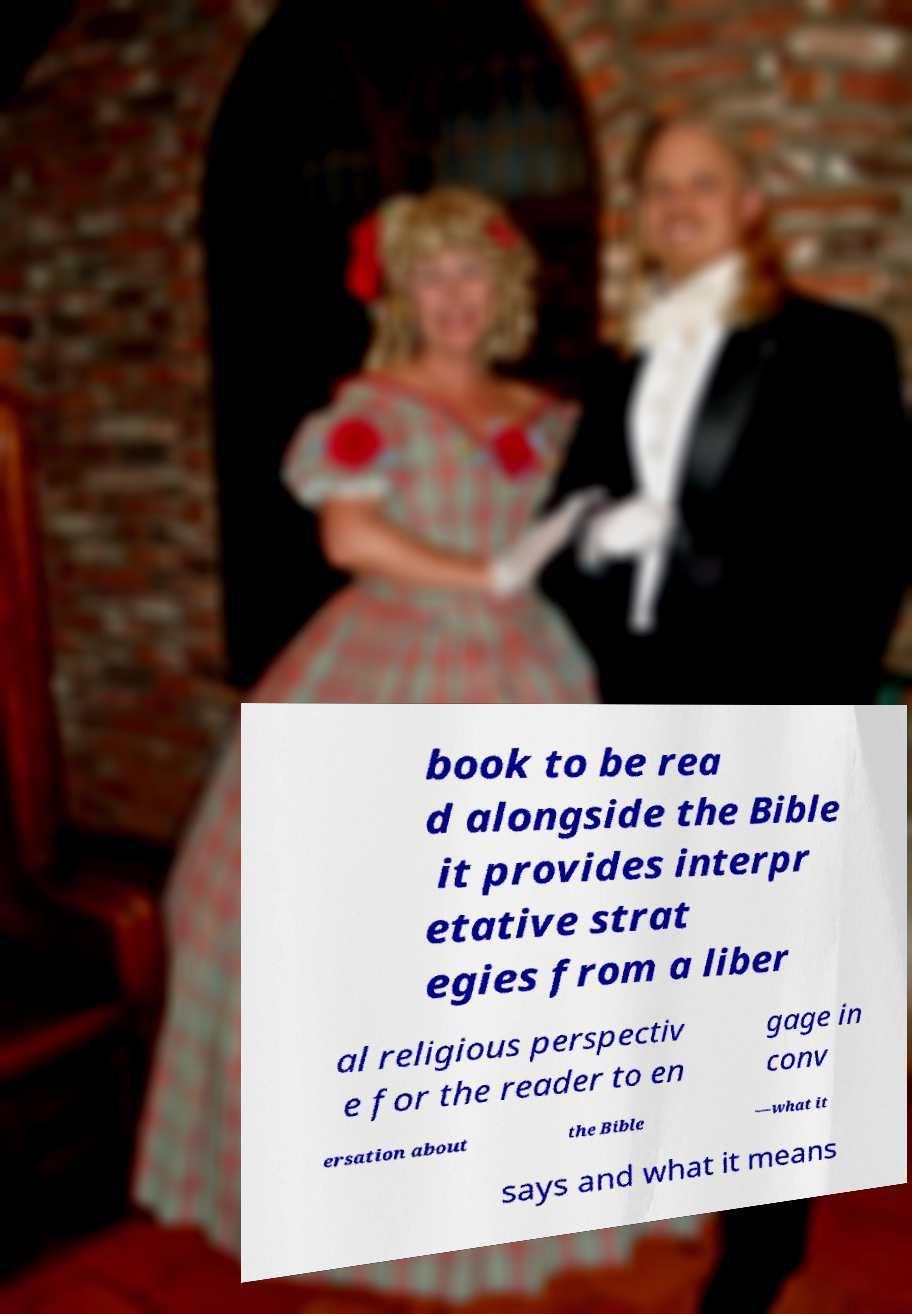Could you assist in decoding the text presented in this image and type it out clearly? book to be rea d alongside the Bible it provides interpr etative strat egies from a liber al religious perspectiv e for the reader to en gage in conv ersation about the Bible —what it says and what it means 